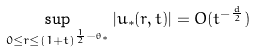<formula> <loc_0><loc_0><loc_500><loc_500>\sup _ { 0 \leq r \leq ( 1 + t ) ^ { \frac { 1 } { 2 } - \theta _ { * } } } | u _ { * } ( r , t ) | = O ( t ^ { - \frac { d } { 2 } } )</formula> 